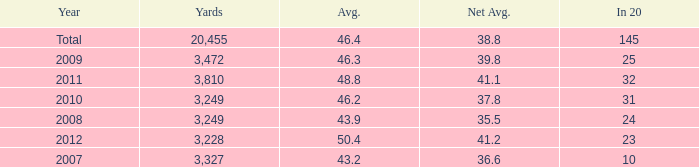What number of Yards has 32 as an In 20? 1.0. 